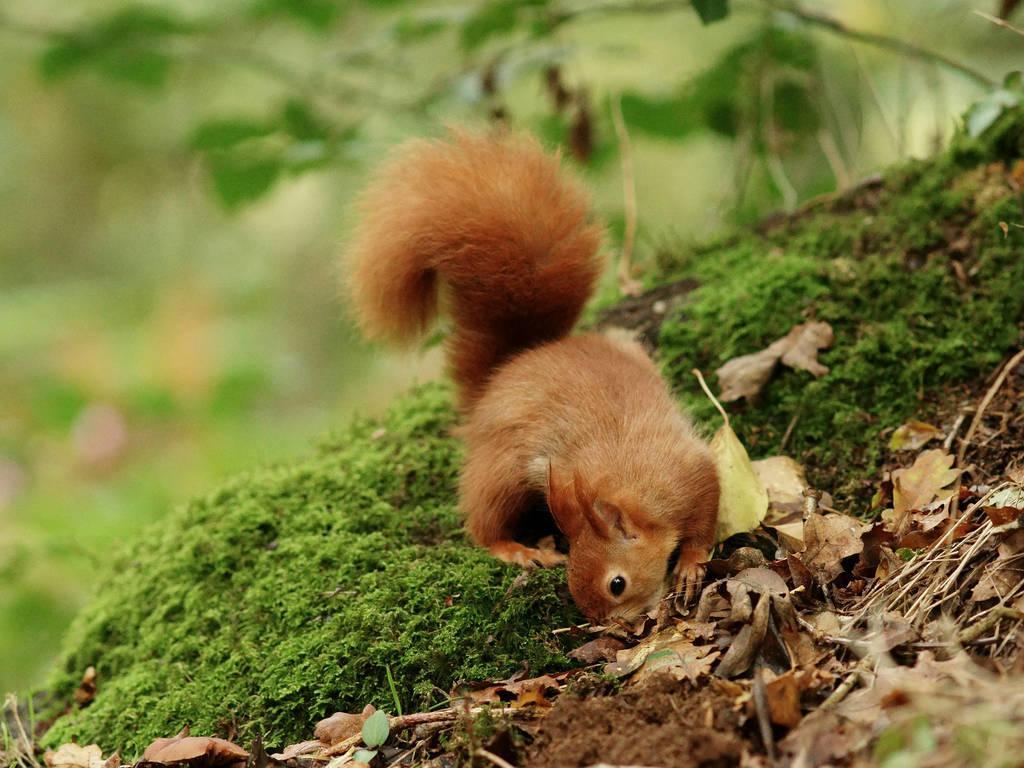In one or two sentences, can you explain what this image depicts? As we can see in the image there is grass, squirrel and plant. The background is blurred. 